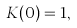Convert formula to latex. <formula><loc_0><loc_0><loc_500><loc_500>K ( 0 ) = 1 ,</formula> 